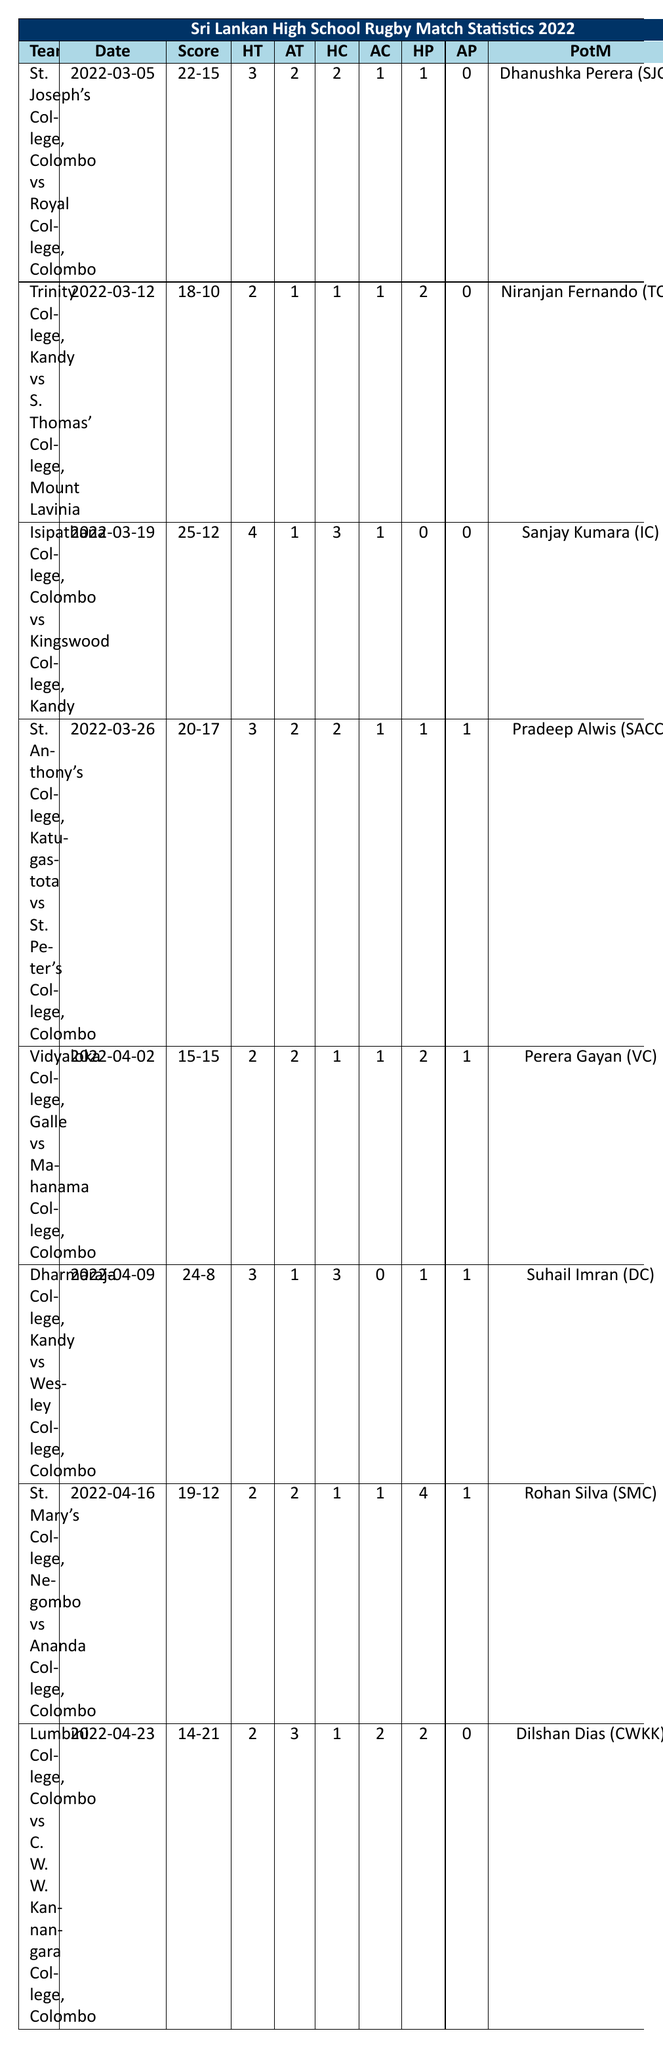What was the highest score achieved by a home team? The home team with the highest score is Dharmaraja College with a score of 24, which can be identified directly from the score column.
Answer: 24 Who won the match between St. Joseph's College and Royal College? St. Joseph's College scored 22 points, while Royal College scored 15 points. Therefore, St. Joseph's College won the match.
Answer: St. Joseph's College How many tries did Dharmaraja College score? Dharmaraja College scored 3 tries as indicated in the table under the "HT" column for their match.
Answer: 3 What is the total number of penalties awarded to St. Anthony's College throughout their match? St. Anthony's College was awarded 1 penalty, as seen in the "HP" column for their match against St. Peter's College.
Answer: 1 What was the score of the match between Vidyaloka College and Mahanama College? The score was a draw, 15-15, as stated in the "Score" column for that match.
Answer: 15-15 Which team had the most tries in a single match and how many? Isipathana College had the most tries in their match against Kingswood College, scoring 4 tries as shown in the "HT" column.
Answer: Isipathana College, 4 tries Did any match end in a draw? Yes, the match between Vidyaloka College and Mahanama College ended in a draw with both teams scoring 15 points. This is shown in the "Score" column.
Answer: Yes What was the average number of tries scored by away teams in the matches listed? The sum of away tries is (2 + 1 + 1 + 2 + 2 + 1 + 2 + 3) = 14, and there are 8 matches, thus the average is 14/8 = 1.75.
Answer: 1.75 Which player was recognized as Player of the Match for the game between Lumbini College and C. W. W. Kannangara College? Dilshan Dias was awarded Player of the Match, as indicated in the corresponding column for that match.
Answer: Dilshan Dias What is the difference in total penalties between home and away teams for the match between St. Mary's College and Ananda College? St. Mary's College had 4 penalties, and Ananda College had 1 penalty, so the difference is 4 - 1 = 3.
Answer: 3 What do the away team's total scores add up to across all matches? The total away scores are (15 + 10 + 12 + 17 + 15 + 8 + 12 + 21) = 100.
Answer: 100 